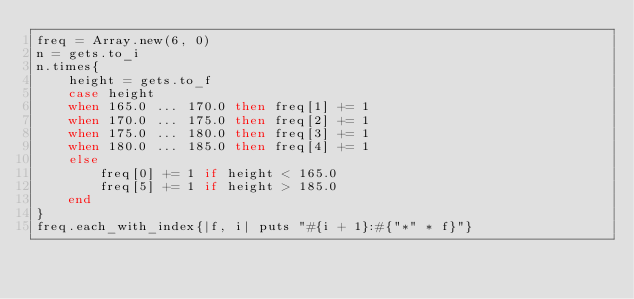Convert code to text. <code><loc_0><loc_0><loc_500><loc_500><_Ruby_>freq = Array.new(6, 0)
n = gets.to_i
n.times{
    height = gets.to_f
    case height
    when 165.0 ... 170.0 then freq[1] += 1
    when 170.0 ... 175.0 then freq[2] += 1
    when 175.0 ... 180.0 then freq[3] += 1
    when 180.0 ... 185.0 then freq[4] += 1
    else
        freq[0] += 1 if height < 165.0
        freq[5] += 1 if height > 185.0
    end
}
freq.each_with_index{|f, i| puts "#{i + 1}:#{"*" * f}"}</code> 